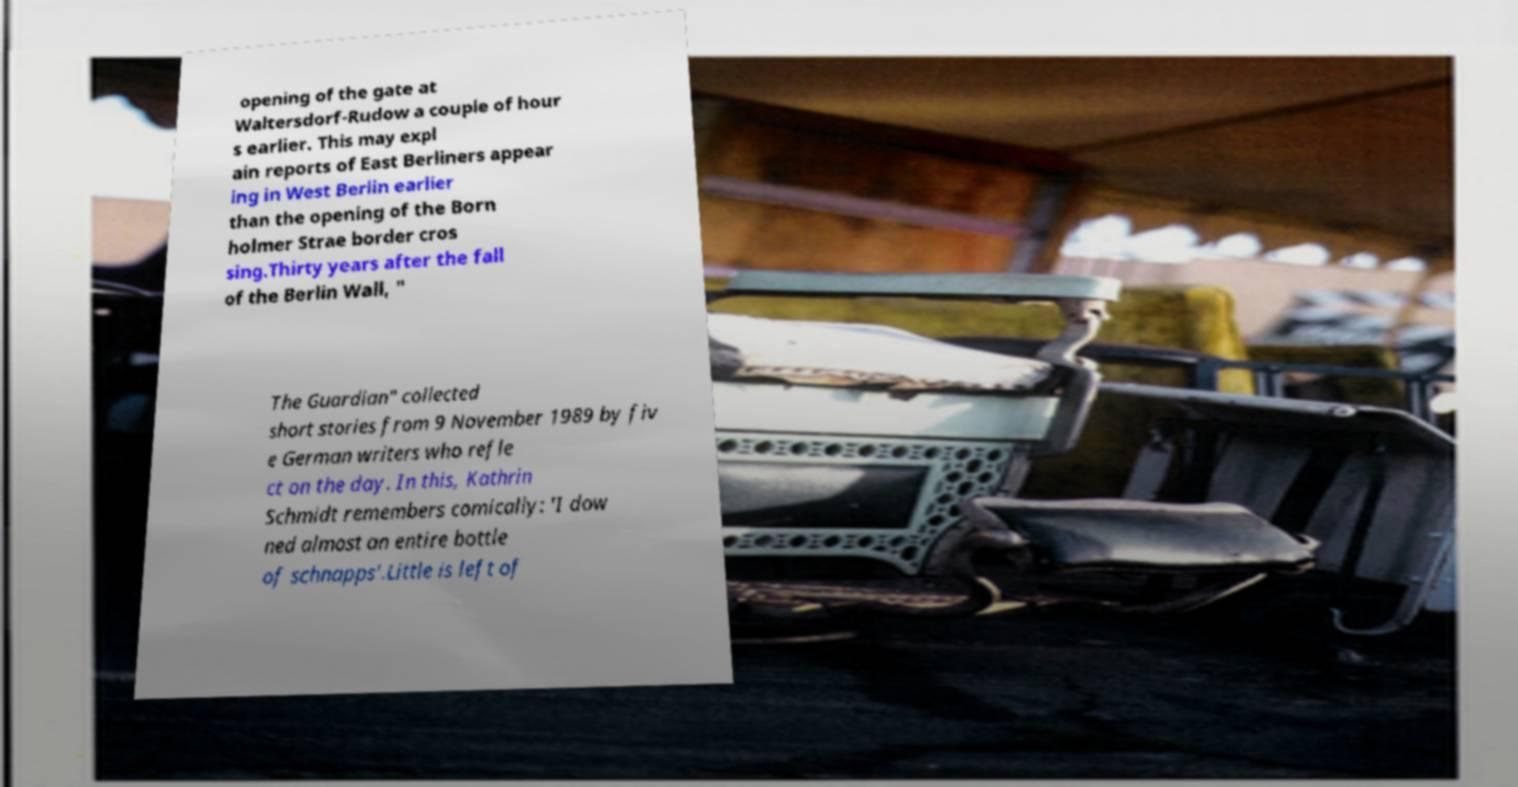Can you accurately transcribe the text from the provided image for me? opening of the gate at Waltersdorf-Rudow a couple of hour s earlier. This may expl ain reports of East Berliners appear ing in West Berlin earlier than the opening of the Born holmer Strae border cros sing.Thirty years after the fall of the Berlin Wall, " The Guardian" collected short stories from 9 November 1989 by fiv e German writers who refle ct on the day. In this, Kathrin Schmidt remembers comically: 'I dow ned almost an entire bottle of schnapps'.Little is left of 